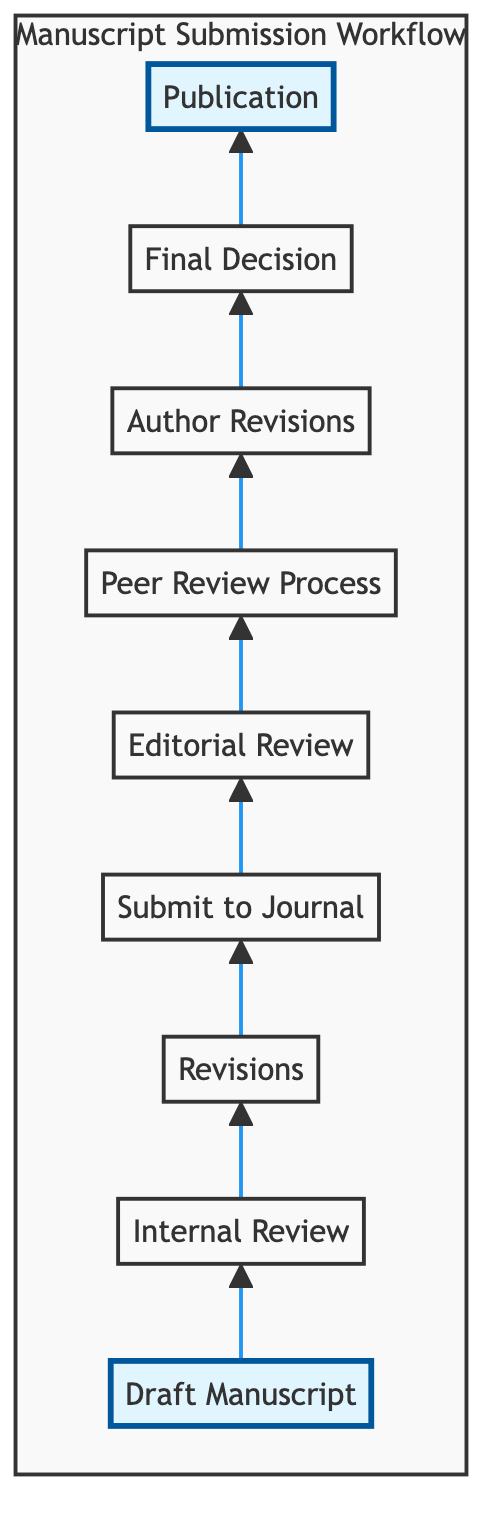What is the first step in the manuscript submission workflow? The first step in the diagram is "Draft Manuscript", which clearly indicates where the process begins.
Answer: Draft Manuscript How many main stages are there in the workflow? Counting the identified nodes in the diagram, there are a total of 9 stages in the workflow from drafting to publication.
Answer: 9 Which step comes immediately after "Internal Review"? Following the "Internal Review" step in the diagram is the "Revisions" step, indicating the sequence from receiving feedback to making adjustments.
Answer: Revisions What are the possible outcomes listed in the "Final Decision" step? The "Final Decision" step lists outcomes such as accept, minor revision, major revision, or reject, reflecting the editor's judgment based on reviews.
Answer: accept, minor revision, major revision, reject What is the terminal step in the manuscript submission workflow? The last step in the workflow is "Publication", indicating that the process concludes with the accepted manuscript being prepared for journal publication.
Answer: Publication What process follows "Peer Review Process"? After "Peer Review Process", the next step is "Author Revisions", which involves the authors making necessary changes based on the feedback received.
Answer: Author Revisions What does the "Editorial Review" assess? The "Editorial Review" assesses whether the manuscript fits the journal's scope, serving as an initial filter before deeper evaluations occur.
Answer: journal's scope In the context of this workflow, who provides feedback during the "Internal Review"? The "Internal Review" stage involves feedback from colleagues and the mentor, indicating collaboration and input from trusted sources before submission.
Answer: colleagues and mentor Which stage requires responding to reviewer comments? The stage that requires responding to reviewer comments is "Author Revisions", as authors make changes based on feedback from the peer review process.
Answer: Author Revisions 